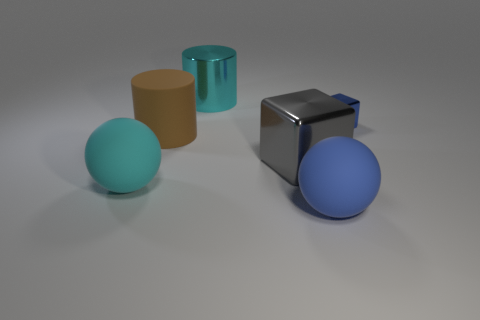Add 1 blue things. How many objects exist? 7 Subtract all cylinders. How many objects are left? 4 Add 6 brown objects. How many brown objects are left? 7 Add 4 blue matte blocks. How many blue matte blocks exist? 4 Subtract 1 blue blocks. How many objects are left? 5 Subtract all small green matte cubes. Subtract all big brown objects. How many objects are left? 5 